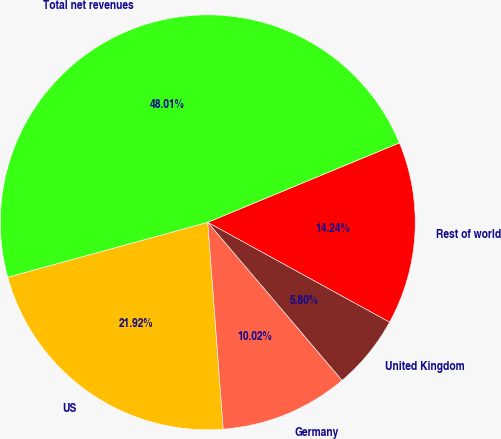<chart> <loc_0><loc_0><loc_500><loc_500><pie_chart><fcel>US<fcel>Germany<fcel>United Kingdom<fcel>Rest of world<fcel>Total net revenues<nl><fcel>21.92%<fcel>10.02%<fcel>5.8%<fcel>14.24%<fcel>48.01%<nl></chart> 